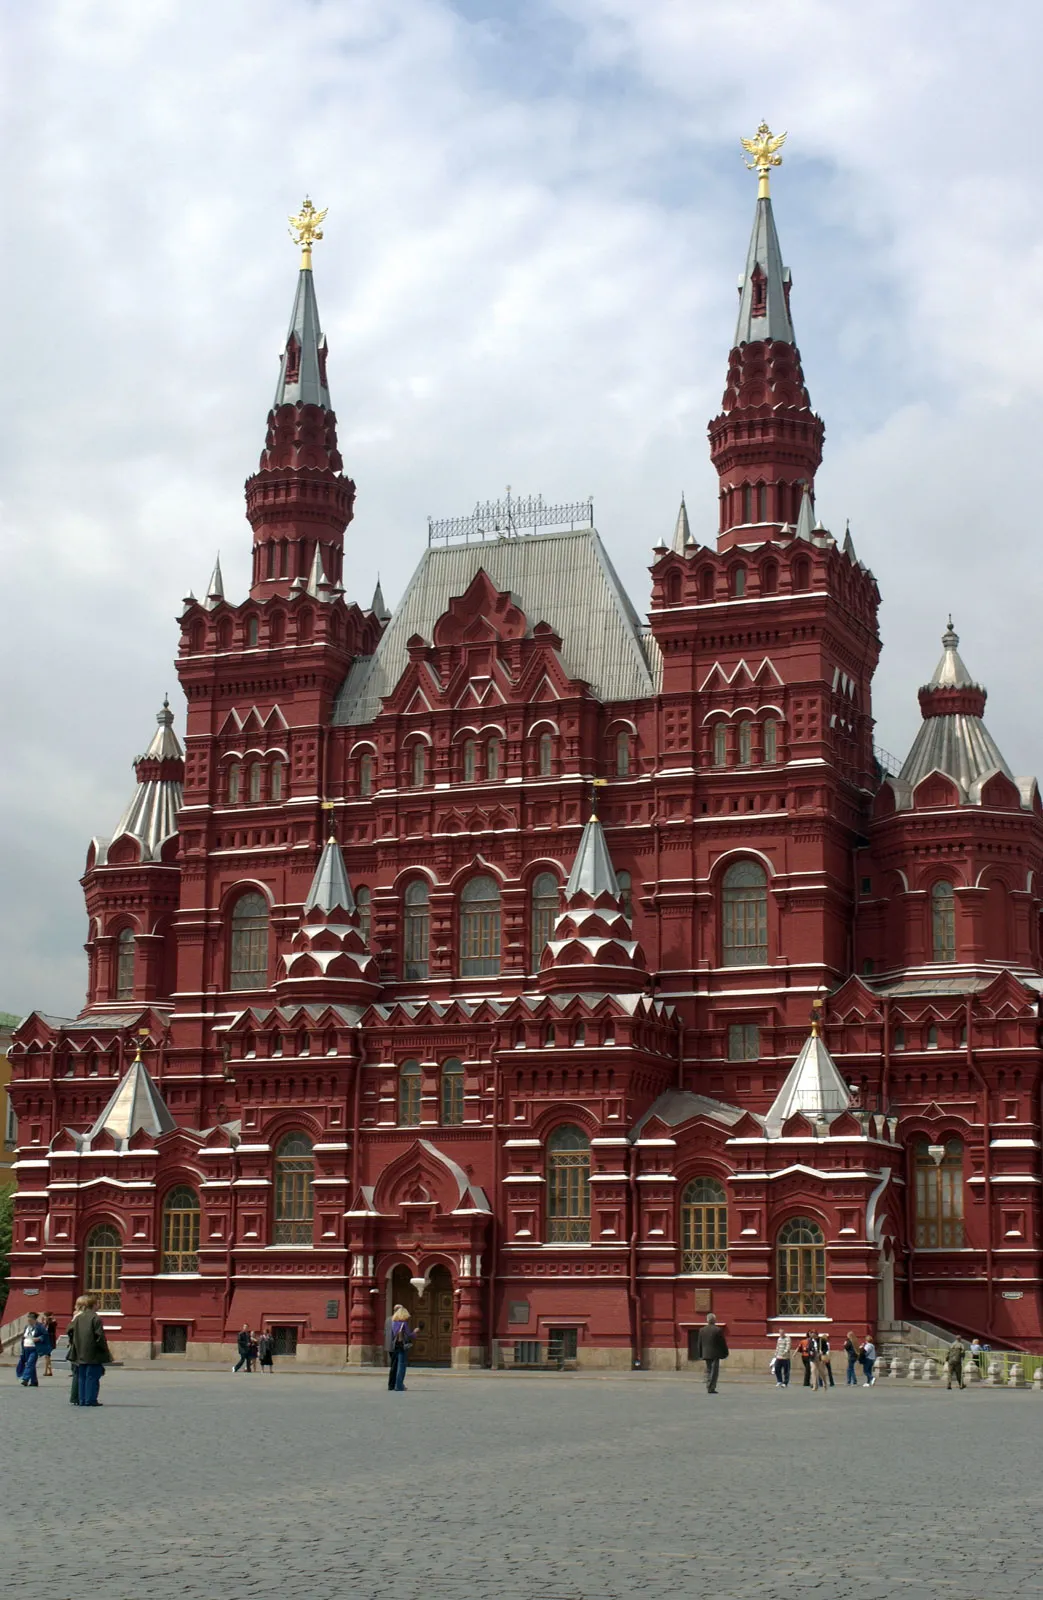Can you tell me more about the historical significance of this building? Certainly! The State Historical Museum, as depicted in this image, was established in 1872 and opened to the public in 1883. It is located between Red Square and Manezh Square in Moscow. The museum's design is a testament to nationalistic influences during its time of construction, intended to celebrate and preserve the diverse history of Russia. It houses millions of artifacts, ranging from prehistoric relics like mammoth tusks and ancient carvings to more recent items from the Romanov era and Soviet Union. 